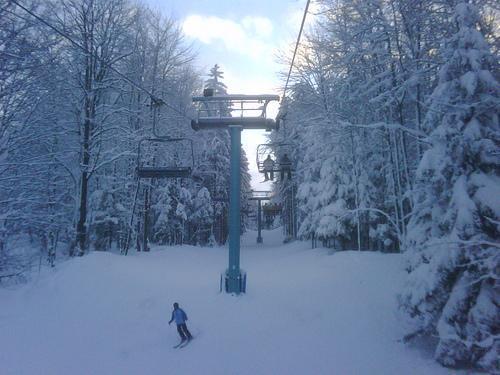How many people in the ski lift?
Give a very brief answer. 2. How many signs are hanging above the toilet that are not written in english?
Give a very brief answer. 0. 